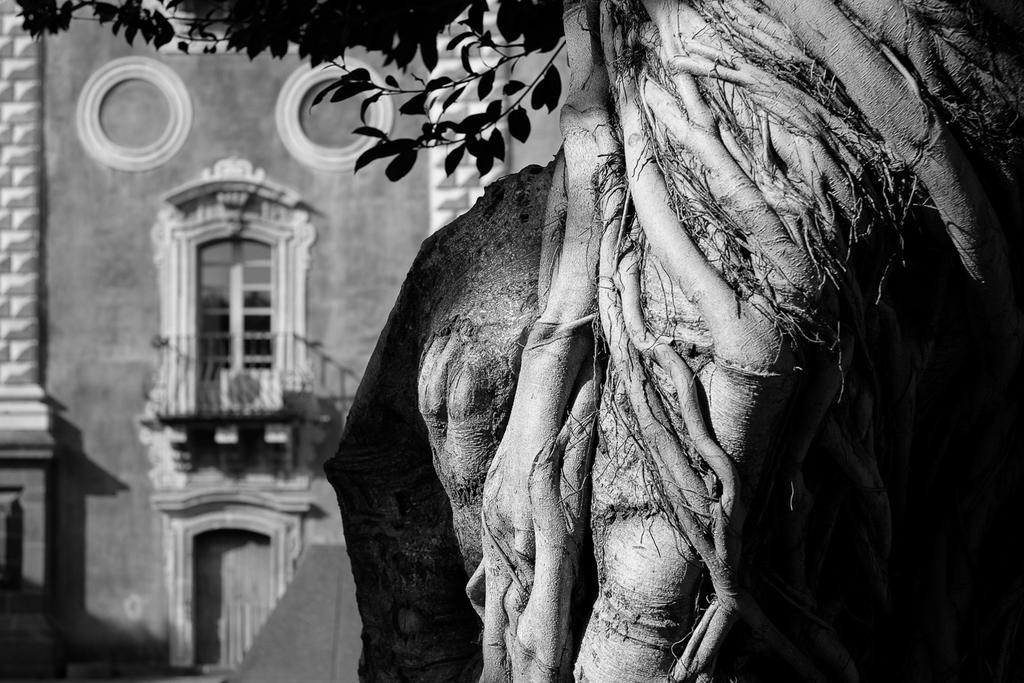What is the color scheme of the image? The image is black and white. What natural element can be seen in the image? There is a tree in the image. Can you describe the tree in the image? The tree has branches, leaves, and roots. What type of structure is visible in the background of the image? There is a building in the background of the image. What features can be seen on the building? The building has a window and a door. How many fields are visible in the image? There are no fields visible in the image; it features a tree and a building. What type of design can be seen on the beggar's clothing in the image? There is no beggar present in the image, so it is not possible to determine the design on their clothing. 